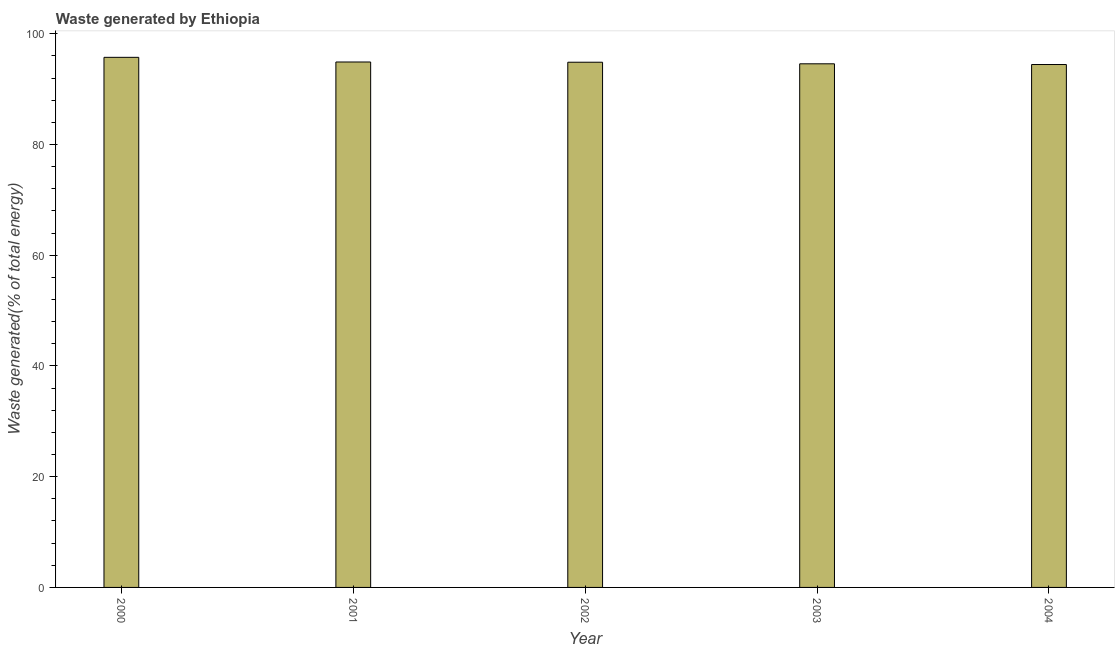Does the graph contain any zero values?
Your answer should be compact. No. What is the title of the graph?
Offer a very short reply. Waste generated by Ethiopia. What is the label or title of the Y-axis?
Give a very brief answer. Waste generated(% of total energy). What is the amount of waste generated in 2000?
Ensure brevity in your answer.  95.74. Across all years, what is the maximum amount of waste generated?
Provide a succinct answer. 95.74. Across all years, what is the minimum amount of waste generated?
Provide a short and direct response. 94.44. In which year was the amount of waste generated minimum?
Your answer should be very brief. 2004. What is the sum of the amount of waste generated?
Ensure brevity in your answer.  474.5. What is the difference between the amount of waste generated in 2002 and 2003?
Provide a succinct answer. 0.28. What is the average amount of waste generated per year?
Make the answer very short. 94.9. What is the median amount of waste generated?
Ensure brevity in your answer.  94.86. What is the ratio of the amount of waste generated in 2000 to that in 2001?
Offer a terse response. 1.01. Is the amount of waste generated in 2000 less than that in 2003?
Give a very brief answer. No. Is the difference between the amount of waste generated in 2000 and 2003 greater than the difference between any two years?
Your answer should be compact. No. What is the difference between the highest and the second highest amount of waste generated?
Your response must be concise. 0.84. What is the difference between the highest and the lowest amount of waste generated?
Provide a succinct answer. 1.3. In how many years, is the amount of waste generated greater than the average amount of waste generated taken over all years?
Provide a succinct answer. 1. How many bars are there?
Provide a short and direct response. 5. Are all the bars in the graph horizontal?
Ensure brevity in your answer.  No. Are the values on the major ticks of Y-axis written in scientific E-notation?
Make the answer very short. No. What is the Waste generated(% of total energy) in 2000?
Provide a short and direct response. 95.74. What is the Waste generated(% of total energy) in 2001?
Offer a very short reply. 94.9. What is the Waste generated(% of total energy) of 2002?
Make the answer very short. 94.86. What is the Waste generated(% of total energy) of 2003?
Ensure brevity in your answer.  94.57. What is the Waste generated(% of total energy) of 2004?
Offer a terse response. 94.44. What is the difference between the Waste generated(% of total energy) in 2000 and 2001?
Ensure brevity in your answer.  0.84. What is the difference between the Waste generated(% of total energy) in 2000 and 2002?
Your answer should be compact. 0.88. What is the difference between the Waste generated(% of total energy) in 2000 and 2003?
Provide a short and direct response. 1.17. What is the difference between the Waste generated(% of total energy) in 2000 and 2004?
Your answer should be compact. 1.3. What is the difference between the Waste generated(% of total energy) in 2001 and 2002?
Provide a short and direct response. 0.04. What is the difference between the Waste generated(% of total energy) in 2001 and 2003?
Your answer should be compact. 0.33. What is the difference between the Waste generated(% of total energy) in 2001 and 2004?
Make the answer very short. 0.46. What is the difference between the Waste generated(% of total energy) in 2002 and 2003?
Provide a short and direct response. 0.29. What is the difference between the Waste generated(% of total energy) in 2002 and 2004?
Offer a very short reply. 0.41. What is the difference between the Waste generated(% of total energy) in 2003 and 2004?
Your response must be concise. 0.13. What is the ratio of the Waste generated(% of total energy) in 2000 to that in 2001?
Your answer should be compact. 1.01. What is the ratio of the Waste generated(% of total energy) in 2000 to that in 2002?
Give a very brief answer. 1.01. What is the ratio of the Waste generated(% of total energy) in 2001 to that in 2002?
Provide a succinct answer. 1. What is the ratio of the Waste generated(% of total energy) in 2003 to that in 2004?
Provide a short and direct response. 1. 